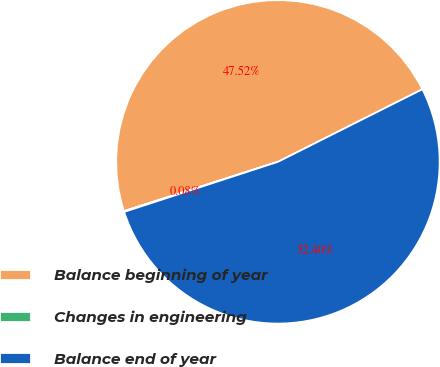Convert chart to OTSL. <chart><loc_0><loc_0><loc_500><loc_500><pie_chart><fcel>Balance beginning of year<fcel>Changes in engineering<fcel>Balance end of year<nl><fcel>47.52%<fcel>0.08%<fcel>52.4%<nl></chart> 